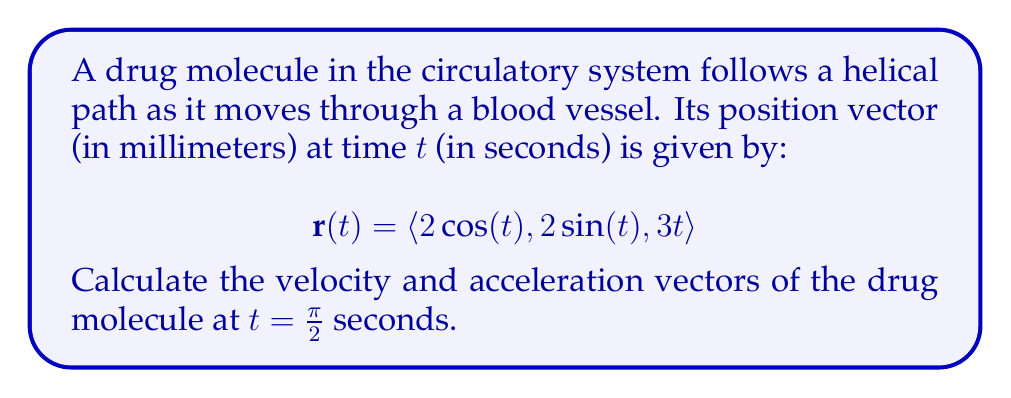Solve this math problem. To solve this problem, we need to follow these steps:

1) Find the velocity vector $\mathbf{v}(t)$ by differentiating $\mathbf{r}(t)$ with respect to $t$:

   $$\mathbf{v}(t) = \frac{d}{dt}\mathbf{r}(t) = \langle -2\sin(t), 2\cos(t), 3 \rangle$$

2) Find the acceleration vector $\mathbf{a}(t)$ by differentiating $\mathbf{v}(t)$ with respect to $t$:

   $$\mathbf{a}(t) = \frac{d}{dt}\mathbf{v}(t) = \langle -2\cos(t), -2\sin(t), 0 \rangle$$

3) Evaluate $\mathbf{v}(t)$ at $t = \frac{\pi}{2}$:

   $$\mathbf{v}(\frac{\pi}{2}) = \langle -2\sin(\frac{\pi}{2}), 2\cos(\frac{\pi}{2}), 3 \rangle = \langle -2, 0, 3 \rangle$$

4) Evaluate $\mathbf{a}(t)$ at $t = \frac{\pi}{2}$:

   $$\mathbf{a}(\frac{\pi}{2}) = \langle -2\cos(\frac{\pi}{2}), -2\sin(\frac{\pi}{2}), 0 \rangle = \langle 0, -2, 0 \rangle$$

Therefore, at $t = \frac{\pi}{2}$ seconds, the velocity vector is $\langle -2, 0, 3 \rangle$ mm/s and the acceleration vector is $\langle 0, -2, 0 \rangle$ mm/s².
Answer: Velocity vector at $t = \frac{\pi}{2}$: $\langle -2, 0, 3 \rangle$ mm/s
Acceleration vector at $t = \frac{\pi}{2}$: $\langle 0, -2, 0 \rangle$ mm/s² 